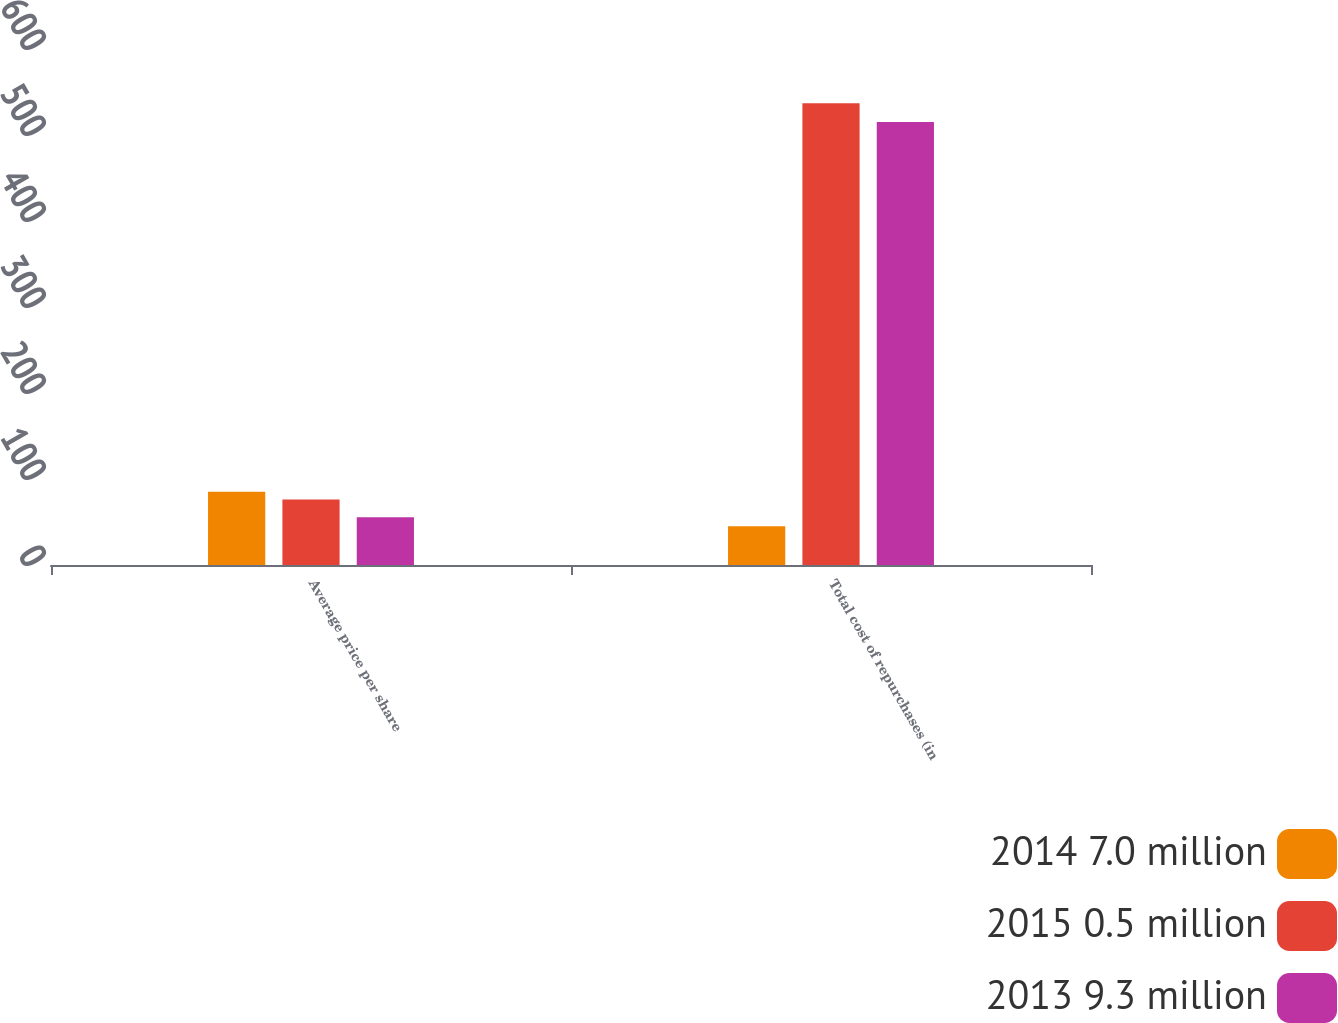<chart> <loc_0><loc_0><loc_500><loc_500><stacked_bar_chart><ecel><fcel>Average price per share<fcel>Total cost of repurchases (in<nl><fcel>2014 7.0 million<fcel>85.27<fcel>45<nl><fcel>2015 0.5 million<fcel>76.26<fcel>537<nl><fcel>2013 9.3 million<fcel>55.59<fcel>515<nl></chart> 